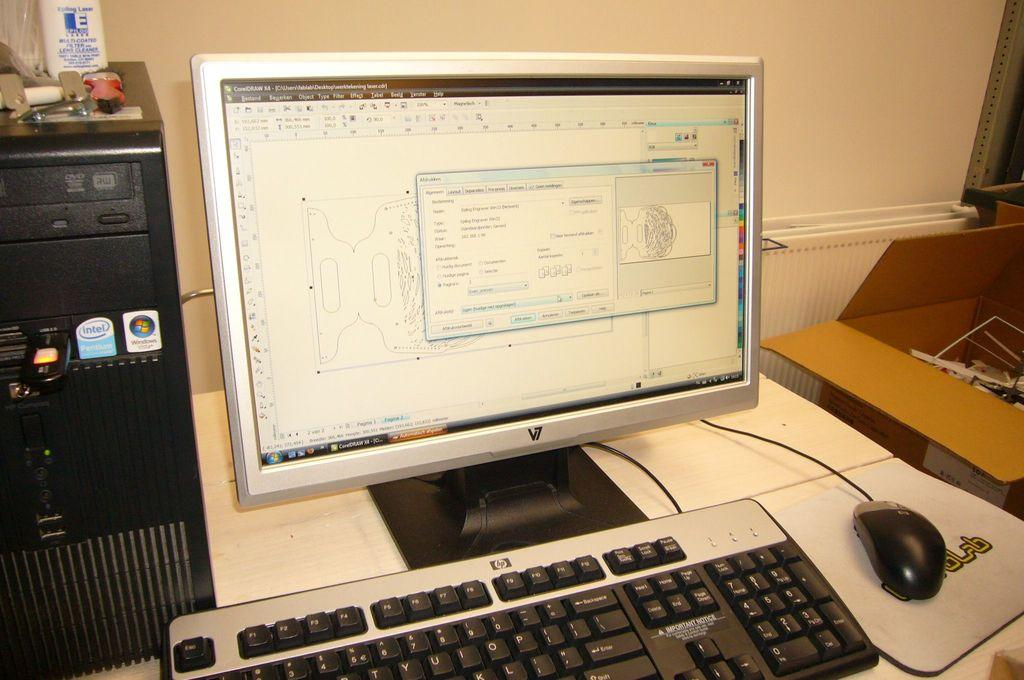Provide a one-sentence caption for the provided image. An HP keyboard and mouse sitting in front of a computer screen that is on. 